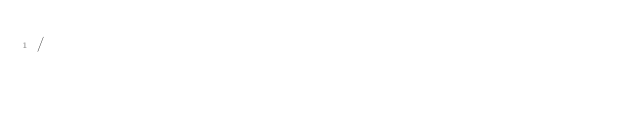Convert code to text. <code><loc_0><loc_0><loc_500><loc_500><_SQL_>/
</code> 